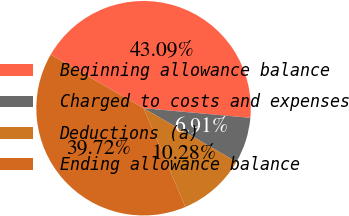<chart> <loc_0><loc_0><loc_500><loc_500><pie_chart><fcel>Beginning allowance balance<fcel>Charged to costs and expenses<fcel>Deductions (a)<fcel>Ending allowance balance<nl><fcel>43.09%<fcel>6.91%<fcel>10.28%<fcel>39.72%<nl></chart> 